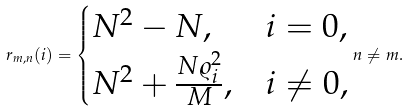<formula> <loc_0><loc_0><loc_500><loc_500>r _ { m , n } ( i ) = \begin{cases} N ^ { 2 } - N , & i = 0 , \\ N ^ { 2 } + \frac { N \varrho _ { i } ^ { 2 } } { M } , & i \neq 0 , \end{cases} n \neq m .</formula> 